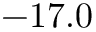<formula> <loc_0><loc_0><loc_500><loc_500>- 1 7 . 0</formula> 